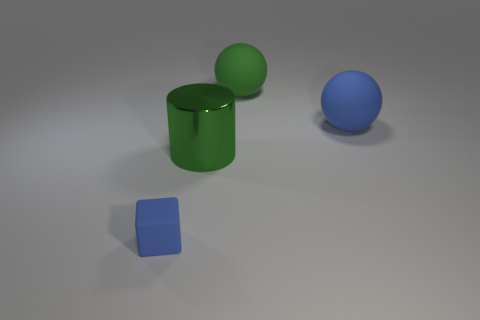Subtract all blue balls. How many balls are left? 1 Subtract 1 cylinders. How many cylinders are left? 0 Add 2 tiny blocks. How many objects exist? 6 Subtract all blue blocks. How many blue spheres are left? 1 Subtract 1 green cylinders. How many objects are left? 3 Subtract all yellow cylinders. Subtract all gray spheres. How many cylinders are left? 1 Subtract all green matte cylinders. Subtract all tiny matte objects. How many objects are left? 3 Add 4 blue rubber cubes. How many blue rubber cubes are left? 5 Add 2 blue cubes. How many blue cubes exist? 3 